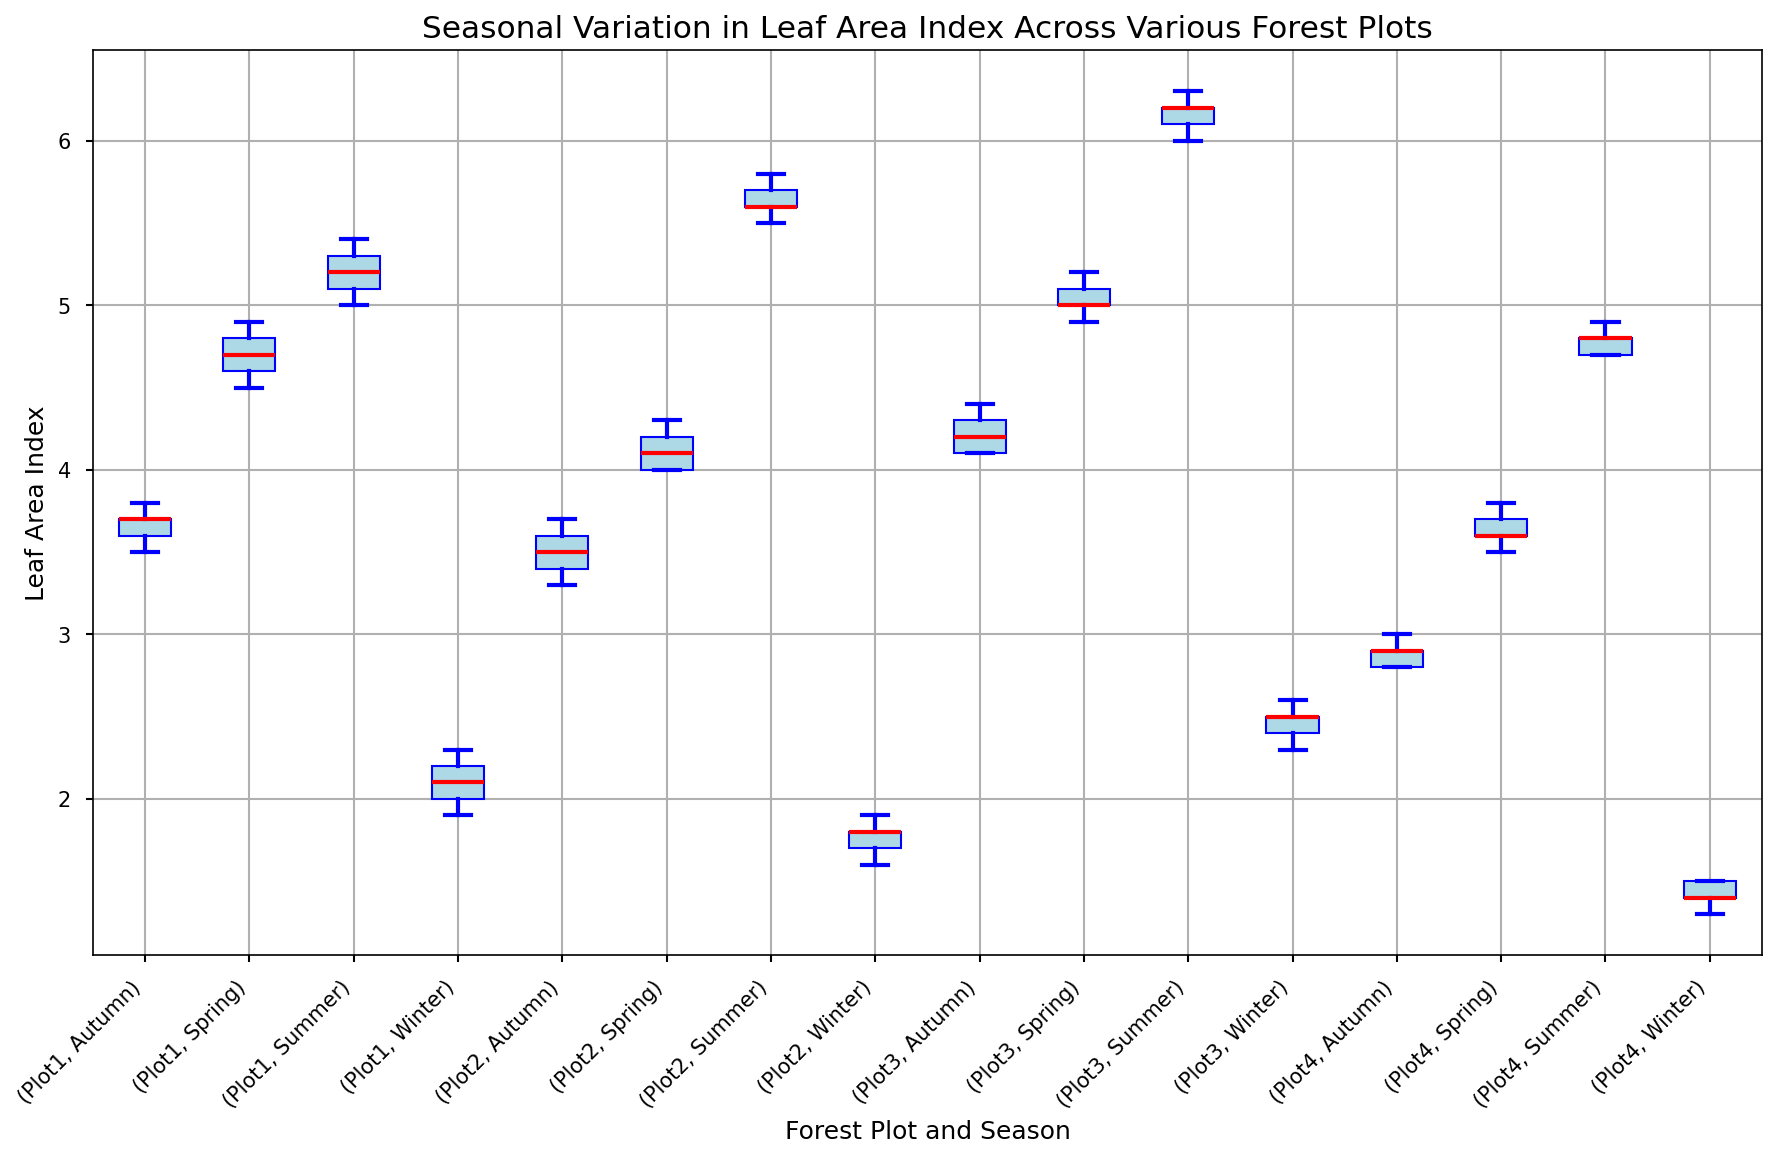What's the median Leaf Area Index (LAI) for Plot 3 during summer? To find the median Leaf Area Index for Plot 3 in summer, locate the box plot for Plot 3 marked "Summer". The red line in the middle of the box in a box plot represents the median value.
Answer: 6.2 Which forest plot has the highest median LAI in winter? To determine which forest plot has the highest median LAI in winter, compare the red median lines of the box plots for all forest plots labeled "Winter". Identify the plot with the highest median line.
Answer: Plot 3 Does Plot 2 have a higher median LAI in autumn compared to Plot 4? Compare the red median lines of the box plots for Plot 2 and Plot 4 under the "Autumn" label. If Plot 2's line is higher, then its median LAI is higher.
Answer: Yes What is the range of the LAI for Plot 1 in spring? The range in a box plot is the difference between the maximum and minimum values, represented by the top and bottom whiskers, respectively. Locate the maximum and minimum points for Plot 1 in spring and subtract the minimum from the maximum.
Answer: 4.9 - 4.5 = 0.4 Among all seasons for Plot 4, which one has the widest interquartile range (IQR)? The IQR is the length of the box in a box plot, representing the middle 50% of data. Compare the lengths of all boxes for Plot 4 across seasons and identify the widest one.
Answer: Summer Which plot has the smallest range of LAI values in summer? The range is the difference between the top and bottom whiskers. Compare the lengths of these ranges for all plots in summer and identify the one with the smallest range.
Answer: Plot 1 For Plot 1, how does the median LAI in autumn compare to the median LAI in winter? Compare the red median lines for Plot 1 in both "Autumn" and "Winter". Determine if the "Autumn" median is higher, lower, or equal to the "Winter" median.
Answer: Higher Which season has the most variation in LAI for Plot 3? In box plots, variation can be seen through the total length from the bottom whisker to the top whisker. For Plot 3, compare the total lengths for each season and determine which is the longest.
Answer: Summer Is the median LAI for Plot 4 in winter lower than the median LAI for Plot 2 in winter? Compare the red median lines for Plot 4 and Plot 2 under the "Winter" label. Determine if Plot 4's median line is lower than Plot 2's.
Answer: Yes 